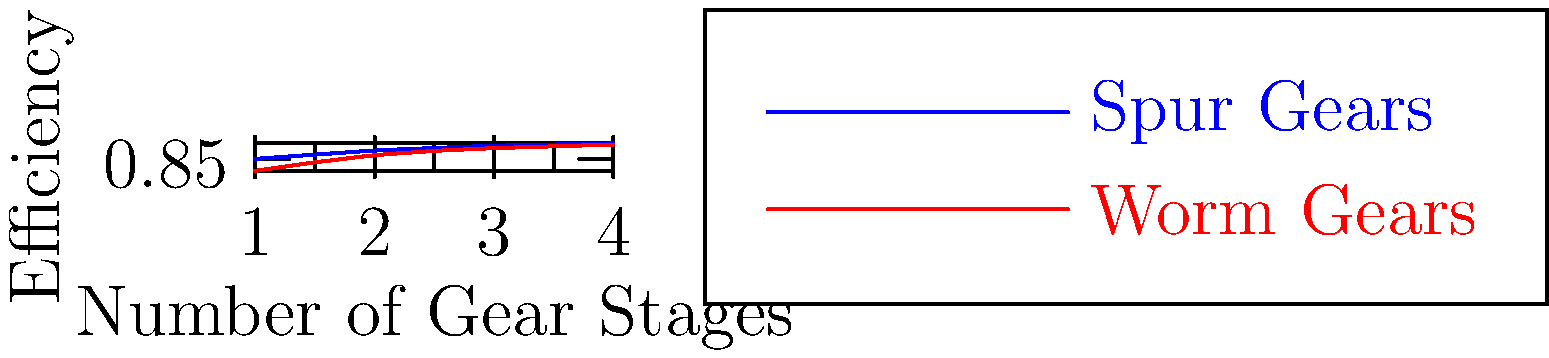As a sculptor interested in kinetic art, you're designing a piece that incorporates gears for power transmission. Given the efficiency graph of spur gears and worm gears, which configuration would you choose for a 3-stage gear system to maximize the artistic impact of smooth, efficient motion? Calculate the overall efficiency of your chosen system. To solve this problem, we'll follow these steps:

1. Identify the efficiencies for 3-stage gear systems:
   - Spur gears: 0.96 (96%)
   - Worm gears: 0.94 (94%)

2. Choose the more efficient system:
   Spur gears have a higher efficiency (96%) compared to worm gears (94%) for a 3-stage system.

3. Calculate the overall efficiency:
   For a multi-stage gear system, we multiply the efficiencies of each stage.
   
   Overall efficiency = $$(0.96)^3 = 0.96 \times 0.96 \times 0.96 = 0.884736$$

4. Convert to percentage:
   $$0.884736 \times 100\% = 88.4736\%$$

Therefore, for maximum efficiency and smooth motion in your kinetic sculpture, you should choose a 3-stage spur gear system with an overall efficiency of approximately 88.47%.
Answer: Spur gear system, 88.47% efficient 